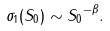<formula> <loc_0><loc_0><loc_500><loc_500>\sigma _ { 1 } ( S _ { 0 } ) \sim { S _ { 0 } } ^ { - \beta } .</formula> 